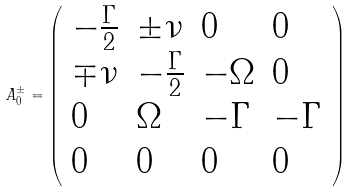Convert formula to latex. <formula><loc_0><loc_0><loc_500><loc_500>A _ { 0 } ^ { \pm } = \left ( \begin{array} { l l l l } - \frac { \Gamma } { 2 } & \pm \nu & 0 & 0 \\ \mp \nu & - \frac { \Gamma } { 2 } & - \Omega & 0 \\ 0 & \Omega & - \Gamma & - \Gamma \\ 0 & 0 & 0 & 0 \end{array} \right )</formula> 